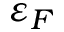<formula> <loc_0><loc_0><loc_500><loc_500>\varepsilon _ { F }</formula> 